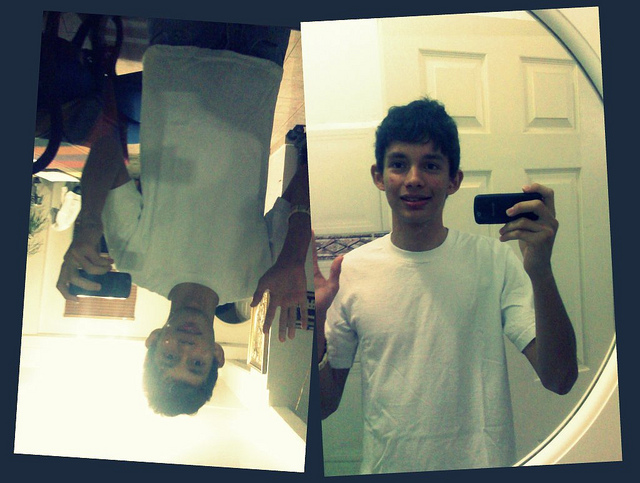Which hand is the person using to hold the phone while taking the selfie? The person is holding the phone with their right hand while taking the selfie. 